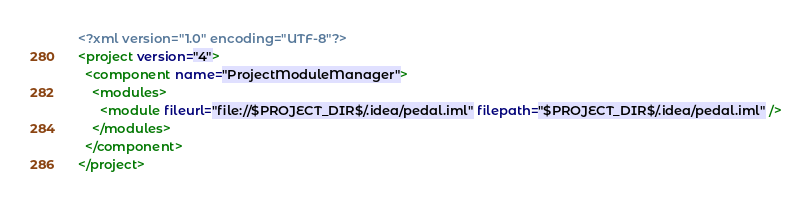<code> <loc_0><loc_0><loc_500><loc_500><_XML_><?xml version="1.0" encoding="UTF-8"?>
<project version="4">
  <component name="ProjectModuleManager">
    <modules>
      <module fileurl="file://$PROJECT_DIR$/.idea/pedal.iml" filepath="$PROJECT_DIR$/.idea/pedal.iml" />
    </modules>
  </component>
</project></code> 